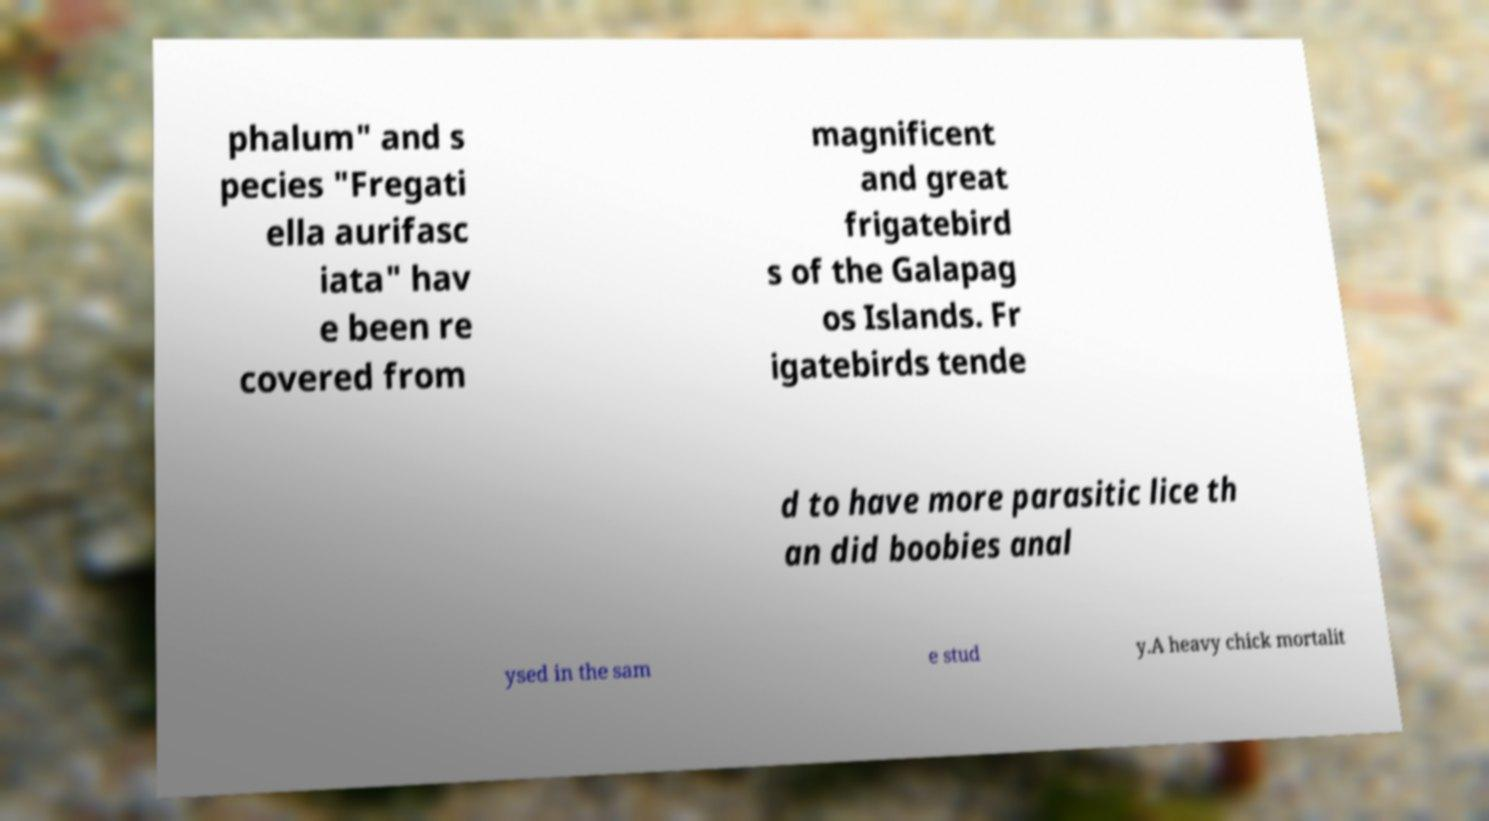Could you extract and type out the text from this image? phalum" and s pecies "Fregati ella aurifasc iata" hav e been re covered from magnificent and great frigatebird s of the Galapag os Islands. Fr igatebirds tende d to have more parasitic lice th an did boobies anal ysed in the sam e stud y.A heavy chick mortalit 